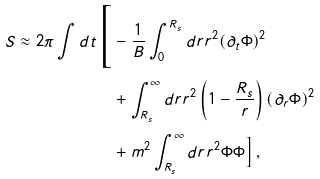Convert formula to latex. <formula><loc_0><loc_0><loc_500><loc_500>S \approx 2 \pi \int d t \Big { [ } & - \frac { 1 } { B } \int _ { 0 } ^ { R _ { s } } d r r ^ { 2 } ( \partial _ { t } \Phi ) ^ { 2 } \\ & + \int _ { R _ { s } } ^ { \infty } d r r ^ { 2 } \left ( 1 - \frac { R _ { s } } { r } \right ) ( \partial _ { r } \Phi ) ^ { 2 } \\ & + m ^ { 2 } \int _ { R _ { s } } ^ { \infty } d r r ^ { 2 } \Phi \Phi \Big { ] } \, ,</formula> 